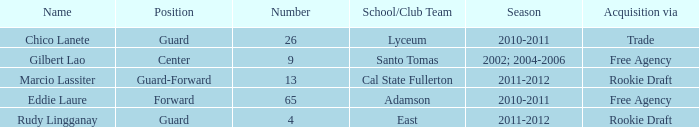What season had Marcio Lassiter? 2011-2012. 